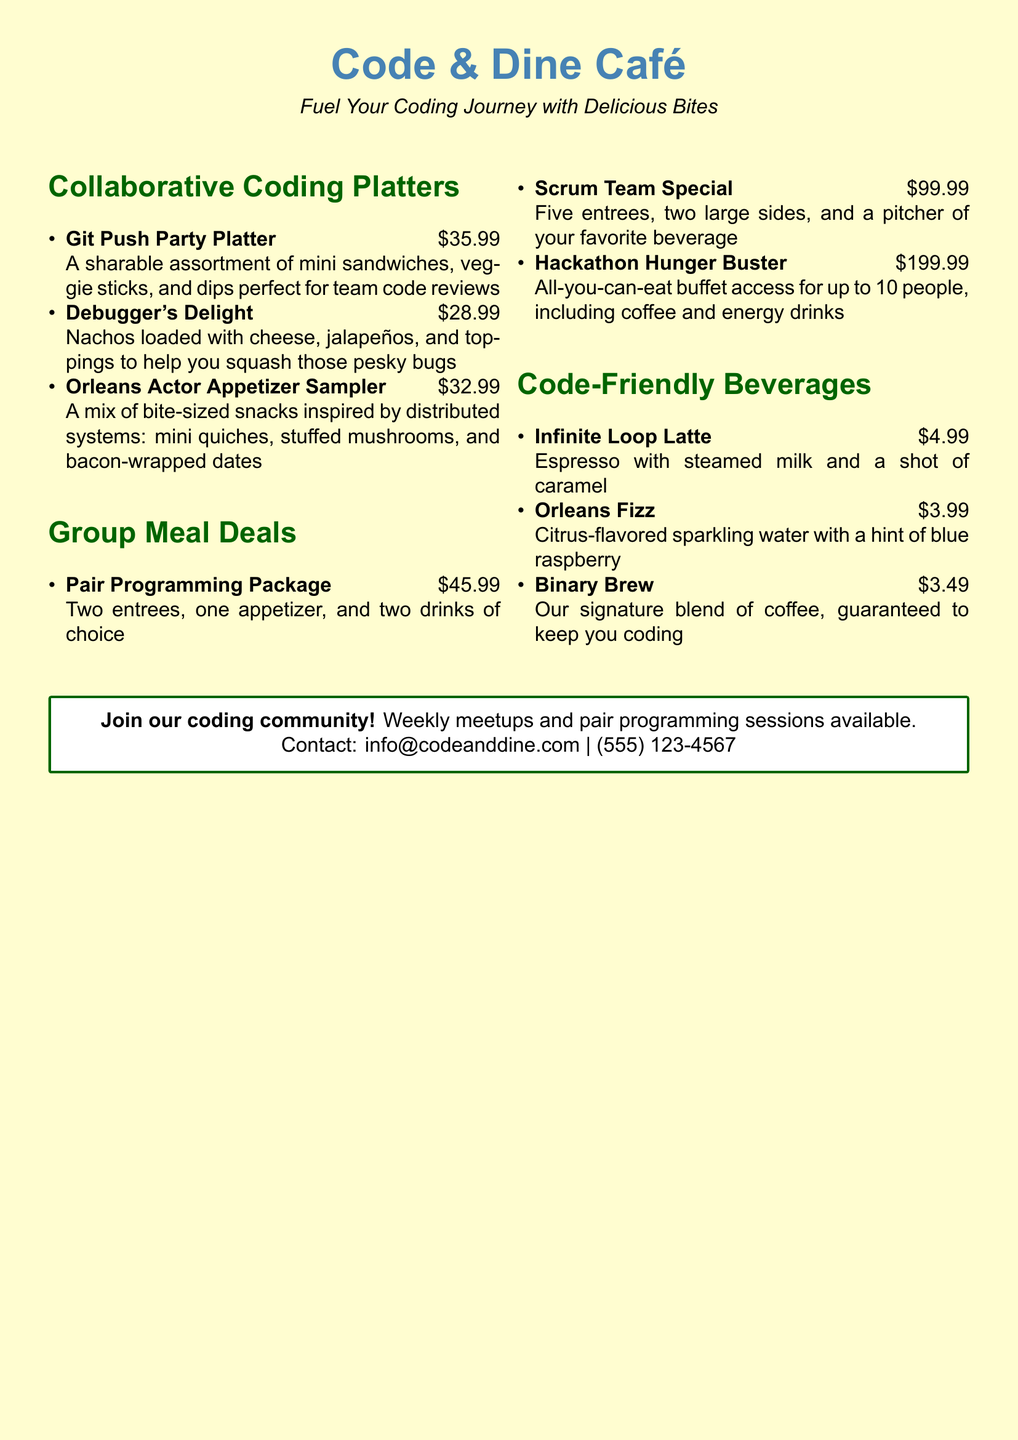what is the name of the café? The name of the café is featured at the top of the document.
Answer: Code & Dine Café what is the price of the Git Push Party Platter? The price is listed next to the dish in the Collaborative Coding Platters section.
Answer: $35.99 how many large sides are included in the Scrum Team Special? The number of large sides is specified in the Group Meal Deals section.
Answer: two what type of beverage is the Infinite Loop Latte? The beverage type is described in the Code-Friendly Beverages section.
Answer: Latte what does the Hackathon Hunger Buster offer? The offer details are provided in the Group Meal Deals section.
Answer: All-you-can-eat buffet access for up to 10 people which dessert is mentioned in the menu? The dessert type is checked in the document, and it appears there are none mentioned.
Answer: None what is the contact number of the café? The contact number is provided in the contact information box at the bottom of the document.
Answer: (555) 123-4567 how many platters are available in the menu? The number of platters can be counted in the Collaborative Coding Platters section.
Answer: three what is the main theme of the café as described in the document? The theme is indicated in the tagline just beneath the café name.
Answer: Fuel Your Coding Journey with Delicious Bites 